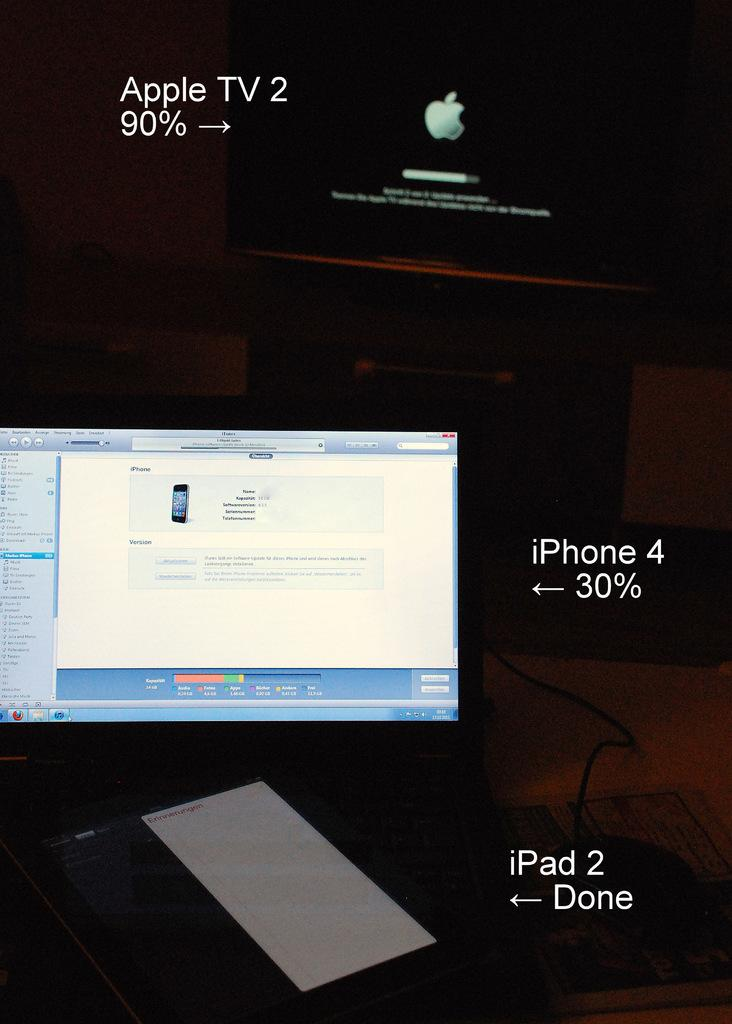Provide a one-sentence caption for the provided image. Laptop and a computer with a iphone 4 and ipad 2 connected to it. 